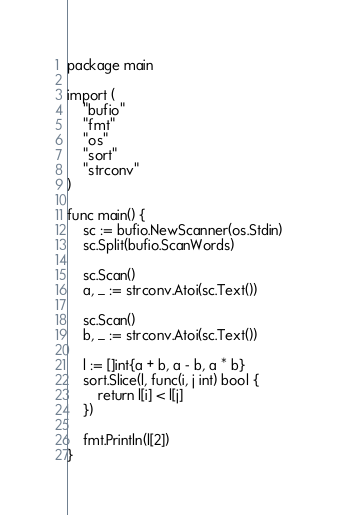Convert code to text. <code><loc_0><loc_0><loc_500><loc_500><_Go_>package main

import (
	"bufio"
	"fmt"
	"os"
	"sort"
	"strconv"
)

func main() {
	sc := bufio.NewScanner(os.Stdin)
	sc.Split(bufio.ScanWords)

	sc.Scan()
	a, _ := strconv.Atoi(sc.Text())

	sc.Scan()
	b, _ := strconv.Atoi(sc.Text())

	l := []int{a + b, a - b, a * b}
	sort.Slice(l, func(i, j int) bool {
		return l[i] < l[j]
	})

	fmt.Println(l[2])
}
</code> 